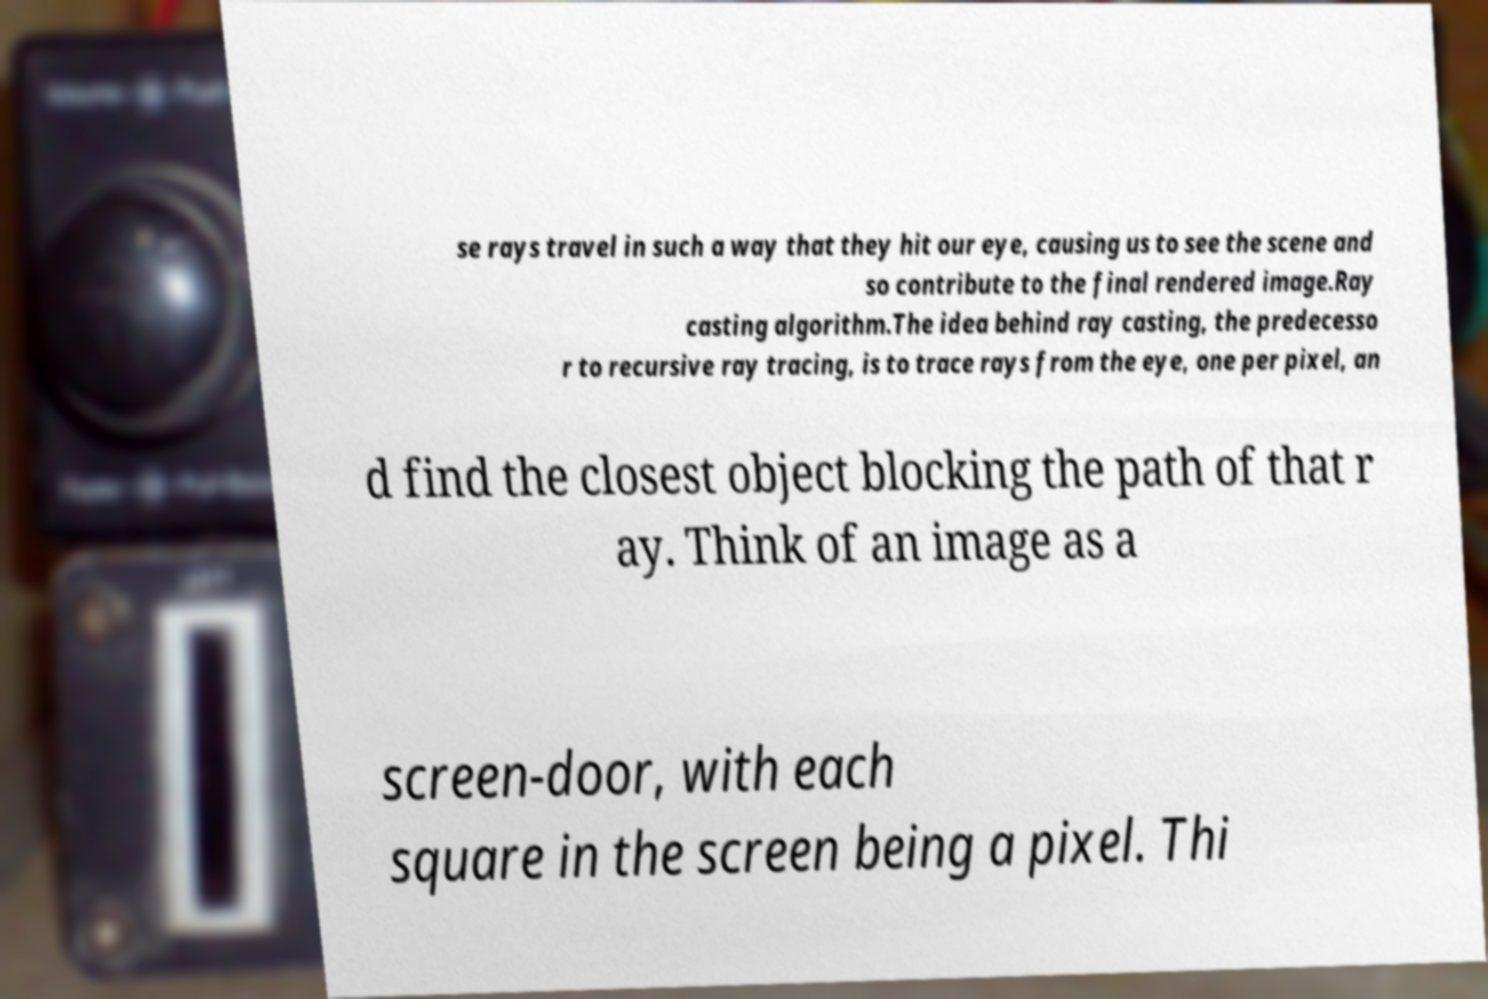Could you extract and type out the text from this image? se rays travel in such a way that they hit our eye, causing us to see the scene and so contribute to the final rendered image.Ray casting algorithm.The idea behind ray casting, the predecesso r to recursive ray tracing, is to trace rays from the eye, one per pixel, an d find the closest object blocking the path of that r ay. Think of an image as a screen-door, with each square in the screen being a pixel. Thi 